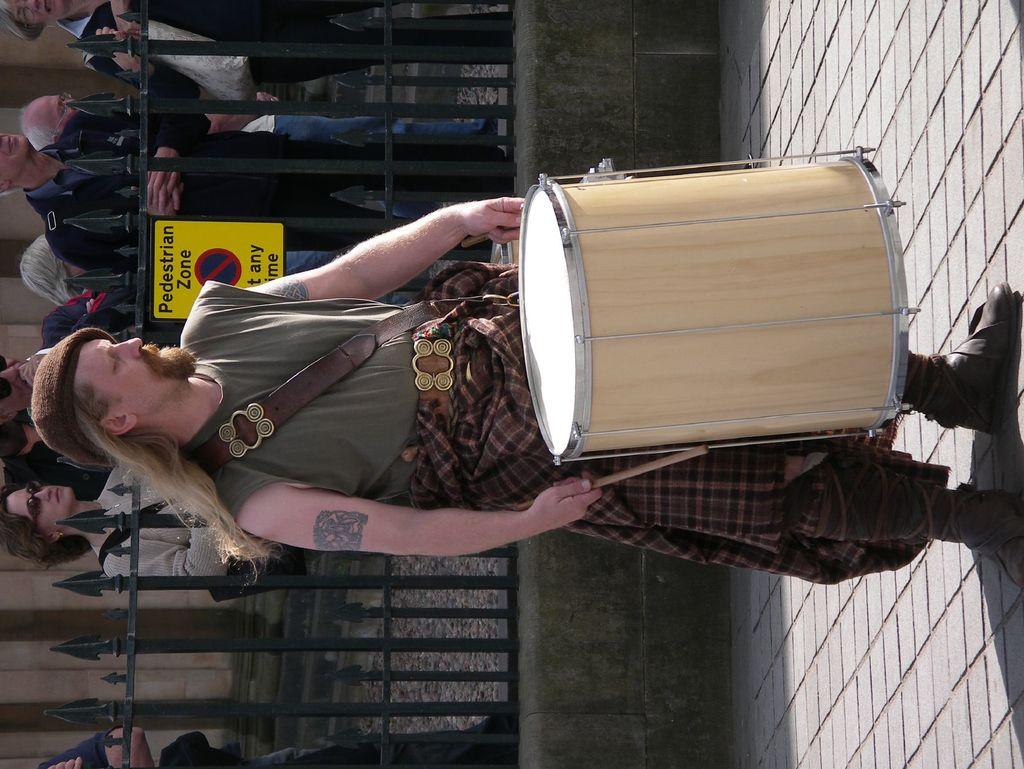What is the man in the image doing? The man is playing a drum. How is the man positioned in the image? The man is standing. What is the man wearing in the image? The man is wearing a grey t-shirt. What can be seen behind the man in the image? There is fencing behind the man. What is happening behind the fencing in the image? There are people standing behind the fencing. What scientific experiment is the man conducting in the image? There is no indication of a scientific experiment in the image; the man is playing a drum. What type of cover is the man using to protect himself from the sun in the image? There is no cover visible in the image; the man is wearing a grey t-shirt. 